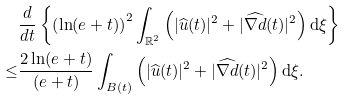<formula> <loc_0><loc_0><loc_500><loc_500>& \frac { d } { d t } \left \{ \left ( \ln ( e + t ) \right ) ^ { 2 } \int _ { \mathbb { R } ^ { 2 } } \left ( | \widehat { u } ( t ) | ^ { 2 } + | \widehat { \nabla d } ( t ) | ^ { 2 } \right ) \text {d} \xi \right \} \\ \leq & \frac { 2 \ln ( e + t ) } { ( e + t ) } \int _ { B ( t ) } \left ( | \widehat { u } ( t ) | ^ { 2 } + | \widehat { \nabla d } ( t ) | ^ { 2 } \right ) \text {d} \xi .</formula> 